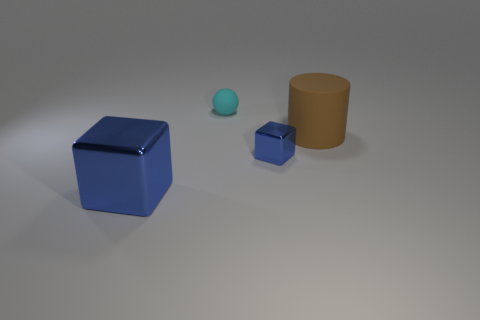What number of cylinders have the same material as the brown thing?
Your answer should be very brief. 0. What is the material of the large thing that is to the left of the rubber ball?
Offer a very short reply. Metal. The large object that is behind the block to the left of the small thing in front of the cylinder is what shape?
Make the answer very short. Cylinder. There is a large object to the left of the brown cylinder; does it have the same color as the object that is behind the brown object?
Ensure brevity in your answer.  No. Is the number of small matte spheres that are in front of the small cyan matte sphere less than the number of cyan things in front of the cylinder?
Ensure brevity in your answer.  No. Are there any other things that have the same shape as the brown thing?
Give a very brief answer. No. What is the color of the other metallic object that is the same shape as the big metal thing?
Your response must be concise. Blue. There is a large brown thing; is its shape the same as the blue object that is to the left of the rubber ball?
Provide a short and direct response. No. What number of things are either large objects that are to the left of the big brown rubber cylinder or metallic blocks that are right of the big blue block?
Your response must be concise. 2. What is the material of the cyan ball?
Provide a short and direct response. Rubber. 